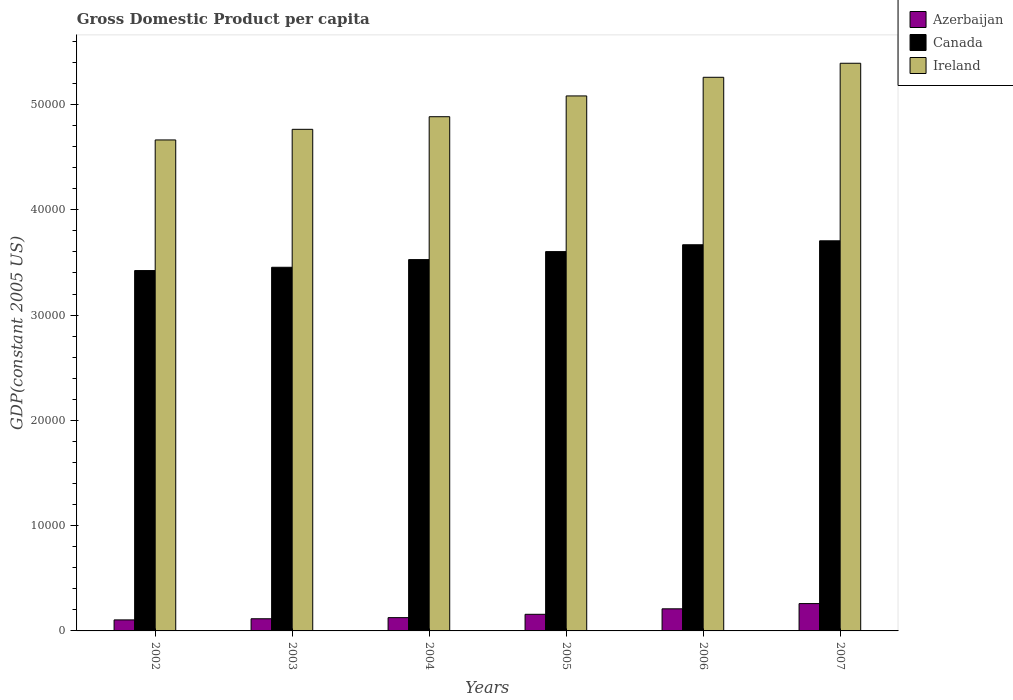How many different coloured bars are there?
Your answer should be compact. 3. How many groups of bars are there?
Offer a terse response. 6. Are the number of bars per tick equal to the number of legend labels?
Give a very brief answer. Yes. Are the number of bars on each tick of the X-axis equal?
Ensure brevity in your answer.  Yes. How many bars are there on the 6th tick from the left?
Provide a short and direct response. 3. How many bars are there on the 5th tick from the right?
Offer a very short reply. 3. What is the label of the 6th group of bars from the left?
Offer a terse response. 2007. In how many cases, is the number of bars for a given year not equal to the number of legend labels?
Your answer should be compact. 0. What is the GDP per capita in Azerbaijan in 2003?
Your answer should be compact. 1154.84. Across all years, what is the maximum GDP per capita in Ireland?
Offer a terse response. 5.39e+04. Across all years, what is the minimum GDP per capita in Azerbaijan?
Give a very brief answer. 1046.42. In which year was the GDP per capita in Canada maximum?
Provide a succinct answer. 2007. What is the total GDP per capita in Ireland in the graph?
Offer a very short reply. 3.00e+05. What is the difference between the GDP per capita in Ireland in 2002 and that in 2003?
Your answer should be compact. -1009.33. What is the difference between the GDP per capita in Azerbaijan in 2007 and the GDP per capita in Canada in 2005?
Make the answer very short. -3.34e+04. What is the average GDP per capita in Ireland per year?
Make the answer very short. 5.01e+04. In the year 2006, what is the difference between the GDP per capita in Azerbaijan and GDP per capita in Canada?
Offer a very short reply. -3.46e+04. In how many years, is the GDP per capita in Canada greater than 50000 US$?
Offer a very short reply. 0. What is the ratio of the GDP per capita in Azerbaijan in 2004 to that in 2006?
Keep it short and to the point. 0.6. Is the difference between the GDP per capita in Azerbaijan in 2004 and 2005 greater than the difference between the GDP per capita in Canada in 2004 and 2005?
Provide a succinct answer. Yes. What is the difference between the highest and the second highest GDP per capita in Azerbaijan?
Offer a very short reply. 496.35. What is the difference between the highest and the lowest GDP per capita in Ireland?
Give a very brief answer. 7283.82. In how many years, is the GDP per capita in Azerbaijan greater than the average GDP per capita in Azerbaijan taken over all years?
Keep it short and to the point. 2. What does the 2nd bar from the left in 2005 represents?
Provide a succinct answer. Canada. What does the 1st bar from the right in 2005 represents?
Provide a short and direct response. Ireland. What is the difference between two consecutive major ticks on the Y-axis?
Provide a succinct answer. 10000. Are the values on the major ticks of Y-axis written in scientific E-notation?
Give a very brief answer. No. Does the graph contain any zero values?
Offer a very short reply. No. How are the legend labels stacked?
Offer a very short reply. Vertical. What is the title of the graph?
Offer a terse response. Gross Domestic Product per capita. Does "Middle income" appear as one of the legend labels in the graph?
Offer a very short reply. No. What is the label or title of the Y-axis?
Provide a short and direct response. GDP(constant 2005 US). What is the GDP(constant 2005 US) of Azerbaijan in 2002?
Your answer should be very brief. 1046.42. What is the GDP(constant 2005 US) of Canada in 2002?
Keep it short and to the point. 3.42e+04. What is the GDP(constant 2005 US) in Ireland in 2002?
Your response must be concise. 4.66e+04. What is the GDP(constant 2005 US) of Azerbaijan in 2003?
Provide a succinct answer. 1154.84. What is the GDP(constant 2005 US) in Canada in 2003?
Your response must be concise. 3.45e+04. What is the GDP(constant 2005 US) in Ireland in 2003?
Provide a short and direct response. 4.76e+04. What is the GDP(constant 2005 US) of Azerbaijan in 2004?
Ensure brevity in your answer.  1261.54. What is the GDP(constant 2005 US) in Canada in 2004?
Provide a short and direct response. 3.53e+04. What is the GDP(constant 2005 US) in Ireland in 2004?
Provide a succinct answer. 4.88e+04. What is the GDP(constant 2005 US) in Azerbaijan in 2005?
Give a very brief answer. 1578.37. What is the GDP(constant 2005 US) in Canada in 2005?
Make the answer very short. 3.60e+04. What is the GDP(constant 2005 US) in Ireland in 2005?
Make the answer very short. 5.08e+04. What is the GDP(constant 2005 US) in Azerbaijan in 2006?
Ensure brevity in your answer.  2099.71. What is the GDP(constant 2005 US) in Canada in 2006?
Keep it short and to the point. 3.67e+04. What is the GDP(constant 2005 US) of Ireland in 2006?
Offer a very short reply. 5.26e+04. What is the GDP(constant 2005 US) of Azerbaijan in 2007?
Offer a terse response. 2596.06. What is the GDP(constant 2005 US) of Canada in 2007?
Offer a very short reply. 3.71e+04. What is the GDP(constant 2005 US) in Ireland in 2007?
Keep it short and to the point. 5.39e+04. Across all years, what is the maximum GDP(constant 2005 US) of Azerbaijan?
Offer a very short reply. 2596.06. Across all years, what is the maximum GDP(constant 2005 US) of Canada?
Provide a short and direct response. 3.71e+04. Across all years, what is the maximum GDP(constant 2005 US) of Ireland?
Keep it short and to the point. 5.39e+04. Across all years, what is the minimum GDP(constant 2005 US) in Azerbaijan?
Offer a very short reply. 1046.42. Across all years, what is the minimum GDP(constant 2005 US) in Canada?
Ensure brevity in your answer.  3.42e+04. Across all years, what is the minimum GDP(constant 2005 US) in Ireland?
Your response must be concise. 4.66e+04. What is the total GDP(constant 2005 US) in Azerbaijan in the graph?
Provide a succinct answer. 9736.94. What is the total GDP(constant 2005 US) of Canada in the graph?
Give a very brief answer. 2.14e+05. What is the total GDP(constant 2005 US) in Ireland in the graph?
Offer a very short reply. 3.00e+05. What is the difference between the GDP(constant 2005 US) of Azerbaijan in 2002 and that in 2003?
Offer a terse response. -108.42. What is the difference between the GDP(constant 2005 US) of Canada in 2002 and that in 2003?
Give a very brief answer. -313.16. What is the difference between the GDP(constant 2005 US) of Ireland in 2002 and that in 2003?
Make the answer very short. -1009.34. What is the difference between the GDP(constant 2005 US) in Azerbaijan in 2002 and that in 2004?
Offer a terse response. -215.12. What is the difference between the GDP(constant 2005 US) of Canada in 2002 and that in 2004?
Offer a terse response. -1042.13. What is the difference between the GDP(constant 2005 US) of Ireland in 2002 and that in 2004?
Offer a terse response. -2206.92. What is the difference between the GDP(constant 2005 US) in Azerbaijan in 2002 and that in 2005?
Keep it short and to the point. -531.95. What is the difference between the GDP(constant 2005 US) of Canada in 2002 and that in 2005?
Provide a succinct answer. -1800.79. What is the difference between the GDP(constant 2005 US) of Ireland in 2002 and that in 2005?
Your answer should be compact. -4181.31. What is the difference between the GDP(constant 2005 US) of Azerbaijan in 2002 and that in 2006?
Ensure brevity in your answer.  -1053.29. What is the difference between the GDP(constant 2005 US) of Canada in 2002 and that in 2006?
Keep it short and to the point. -2451.93. What is the difference between the GDP(constant 2005 US) of Ireland in 2002 and that in 2006?
Offer a terse response. -5950.66. What is the difference between the GDP(constant 2005 US) of Azerbaijan in 2002 and that in 2007?
Give a very brief answer. -1549.64. What is the difference between the GDP(constant 2005 US) in Canada in 2002 and that in 2007?
Provide a succinct answer. -2827.44. What is the difference between the GDP(constant 2005 US) of Ireland in 2002 and that in 2007?
Keep it short and to the point. -7283.82. What is the difference between the GDP(constant 2005 US) in Azerbaijan in 2003 and that in 2004?
Keep it short and to the point. -106.7. What is the difference between the GDP(constant 2005 US) in Canada in 2003 and that in 2004?
Provide a short and direct response. -728.97. What is the difference between the GDP(constant 2005 US) in Ireland in 2003 and that in 2004?
Ensure brevity in your answer.  -1197.58. What is the difference between the GDP(constant 2005 US) in Azerbaijan in 2003 and that in 2005?
Your answer should be very brief. -423.53. What is the difference between the GDP(constant 2005 US) of Canada in 2003 and that in 2005?
Offer a very short reply. -1487.63. What is the difference between the GDP(constant 2005 US) in Ireland in 2003 and that in 2005?
Your response must be concise. -3171.98. What is the difference between the GDP(constant 2005 US) of Azerbaijan in 2003 and that in 2006?
Make the answer very short. -944.87. What is the difference between the GDP(constant 2005 US) of Canada in 2003 and that in 2006?
Your answer should be very brief. -2138.76. What is the difference between the GDP(constant 2005 US) in Ireland in 2003 and that in 2006?
Your answer should be very brief. -4941.33. What is the difference between the GDP(constant 2005 US) in Azerbaijan in 2003 and that in 2007?
Give a very brief answer. -1441.23. What is the difference between the GDP(constant 2005 US) in Canada in 2003 and that in 2007?
Keep it short and to the point. -2514.27. What is the difference between the GDP(constant 2005 US) in Ireland in 2003 and that in 2007?
Provide a short and direct response. -6274.48. What is the difference between the GDP(constant 2005 US) of Azerbaijan in 2004 and that in 2005?
Provide a succinct answer. -316.83. What is the difference between the GDP(constant 2005 US) in Canada in 2004 and that in 2005?
Your answer should be compact. -758.66. What is the difference between the GDP(constant 2005 US) in Ireland in 2004 and that in 2005?
Offer a very short reply. -1974.4. What is the difference between the GDP(constant 2005 US) in Azerbaijan in 2004 and that in 2006?
Ensure brevity in your answer.  -838.17. What is the difference between the GDP(constant 2005 US) of Canada in 2004 and that in 2006?
Ensure brevity in your answer.  -1409.8. What is the difference between the GDP(constant 2005 US) in Ireland in 2004 and that in 2006?
Your response must be concise. -3743.75. What is the difference between the GDP(constant 2005 US) of Azerbaijan in 2004 and that in 2007?
Make the answer very short. -1334.52. What is the difference between the GDP(constant 2005 US) in Canada in 2004 and that in 2007?
Ensure brevity in your answer.  -1785.31. What is the difference between the GDP(constant 2005 US) in Ireland in 2004 and that in 2007?
Provide a succinct answer. -5076.9. What is the difference between the GDP(constant 2005 US) in Azerbaijan in 2005 and that in 2006?
Offer a very short reply. -521.34. What is the difference between the GDP(constant 2005 US) of Canada in 2005 and that in 2006?
Give a very brief answer. -651.14. What is the difference between the GDP(constant 2005 US) in Ireland in 2005 and that in 2006?
Keep it short and to the point. -1769.35. What is the difference between the GDP(constant 2005 US) in Azerbaijan in 2005 and that in 2007?
Ensure brevity in your answer.  -1017.7. What is the difference between the GDP(constant 2005 US) of Canada in 2005 and that in 2007?
Your answer should be compact. -1026.65. What is the difference between the GDP(constant 2005 US) of Ireland in 2005 and that in 2007?
Provide a short and direct response. -3102.5. What is the difference between the GDP(constant 2005 US) of Azerbaijan in 2006 and that in 2007?
Provide a succinct answer. -496.35. What is the difference between the GDP(constant 2005 US) in Canada in 2006 and that in 2007?
Your answer should be compact. -375.51. What is the difference between the GDP(constant 2005 US) of Ireland in 2006 and that in 2007?
Give a very brief answer. -1333.15. What is the difference between the GDP(constant 2005 US) of Azerbaijan in 2002 and the GDP(constant 2005 US) of Canada in 2003?
Ensure brevity in your answer.  -3.35e+04. What is the difference between the GDP(constant 2005 US) of Azerbaijan in 2002 and the GDP(constant 2005 US) of Ireland in 2003?
Offer a terse response. -4.66e+04. What is the difference between the GDP(constant 2005 US) in Canada in 2002 and the GDP(constant 2005 US) in Ireland in 2003?
Ensure brevity in your answer.  -1.34e+04. What is the difference between the GDP(constant 2005 US) in Azerbaijan in 2002 and the GDP(constant 2005 US) in Canada in 2004?
Your answer should be compact. -3.42e+04. What is the difference between the GDP(constant 2005 US) in Azerbaijan in 2002 and the GDP(constant 2005 US) in Ireland in 2004?
Your answer should be very brief. -4.78e+04. What is the difference between the GDP(constant 2005 US) of Canada in 2002 and the GDP(constant 2005 US) of Ireland in 2004?
Provide a short and direct response. -1.46e+04. What is the difference between the GDP(constant 2005 US) of Azerbaijan in 2002 and the GDP(constant 2005 US) of Canada in 2005?
Give a very brief answer. -3.50e+04. What is the difference between the GDP(constant 2005 US) of Azerbaijan in 2002 and the GDP(constant 2005 US) of Ireland in 2005?
Provide a succinct answer. -4.98e+04. What is the difference between the GDP(constant 2005 US) in Canada in 2002 and the GDP(constant 2005 US) in Ireland in 2005?
Your answer should be very brief. -1.66e+04. What is the difference between the GDP(constant 2005 US) of Azerbaijan in 2002 and the GDP(constant 2005 US) of Canada in 2006?
Offer a very short reply. -3.56e+04. What is the difference between the GDP(constant 2005 US) of Azerbaijan in 2002 and the GDP(constant 2005 US) of Ireland in 2006?
Offer a terse response. -5.15e+04. What is the difference between the GDP(constant 2005 US) of Canada in 2002 and the GDP(constant 2005 US) of Ireland in 2006?
Provide a short and direct response. -1.84e+04. What is the difference between the GDP(constant 2005 US) in Azerbaijan in 2002 and the GDP(constant 2005 US) in Canada in 2007?
Your answer should be very brief. -3.60e+04. What is the difference between the GDP(constant 2005 US) in Azerbaijan in 2002 and the GDP(constant 2005 US) in Ireland in 2007?
Your answer should be very brief. -5.29e+04. What is the difference between the GDP(constant 2005 US) in Canada in 2002 and the GDP(constant 2005 US) in Ireland in 2007?
Provide a succinct answer. -1.97e+04. What is the difference between the GDP(constant 2005 US) in Azerbaijan in 2003 and the GDP(constant 2005 US) in Canada in 2004?
Your answer should be compact. -3.41e+04. What is the difference between the GDP(constant 2005 US) of Azerbaijan in 2003 and the GDP(constant 2005 US) of Ireland in 2004?
Your answer should be compact. -4.77e+04. What is the difference between the GDP(constant 2005 US) in Canada in 2003 and the GDP(constant 2005 US) in Ireland in 2004?
Offer a very short reply. -1.43e+04. What is the difference between the GDP(constant 2005 US) in Azerbaijan in 2003 and the GDP(constant 2005 US) in Canada in 2005?
Your answer should be compact. -3.49e+04. What is the difference between the GDP(constant 2005 US) in Azerbaijan in 2003 and the GDP(constant 2005 US) in Ireland in 2005?
Give a very brief answer. -4.97e+04. What is the difference between the GDP(constant 2005 US) of Canada in 2003 and the GDP(constant 2005 US) of Ireland in 2005?
Give a very brief answer. -1.63e+04. What is the difference between the GDP(constant 2005 US) in Azerbaijan in 2003 and the GDP(constant 2005 US) in Canada in 2006?
Offer a terse response. -3.55e+04. What is the difference between the GDP(constant 2005 US) in Azerbaijan in 2003 and the GDP(constant 2005 US) in Ireland in 2006?
Ensure brevity in your answer.  -5.14e+04. What is the difference between the GDP(constant 2005 US) in Canada in 2003 and the GDP(constant 2005 US) in Ireland in 2006?
Offer a very short reply. -1.80e+04. What is the difference between the GDP(constant 2005 US) of Azerbaijan in 2003 and the GDP(constant 2005 US) of Canada in 2007?
Your response must be concise. -3.59e+04. What is the difference between the GDP(constant 2005 US) in Azerbaijan in 2003 and the GDP(constant 2005 US) in Ireland in 2007?
Offer a very short reply. -5.28e+04. What is the difference between the GDP(constant 2005 US) in Canada in 2003 and the GDP(constant 2005 US) in Ireland in 2007?
Your response must be concise. -1.94e+04. What is the difference between the GDP(constant 2005 US) of Azerbaijan in 2004 and the GDP(constant 2005 US) of Canada in 2005?
Make the answer very short. -3.48e+04. What is the difference between the GDP(constant 2005 US) of Azerbaijan in 2004 and the GDP(constant 2005 US) of Ireland in 2005?
Make the answer very short. -4.96e+04. What is the difference between the GDP(constant 2005 US) of Canada in 2004 and the GDP(constant 2005 US) of Ireland in 2005?
Your answer should be compact. -1.55e+04. What is the difference between the GDP(constant 2005 US) in Azerbaijan in 2004 and the GDP(constant 2005 US) in Canada in 2006?
Offer a terse response. -3.54e+04. What is the difference between the GDP(constant 2005 US) in Azerbaijan in 2004 and the GDP(constant 2005 US) in Ireland in 2006?
Keep it short and to the point. -5.13e+04. What is the difference between the GDP(constant 2005 US) in Canada in 2004 and the GDP(constant 2005 US) in Ireland in 2006?
Your answer should be very brief. -1.73e+04. What is the difference between the GDP(constant 2005 US) in Azerbaijan in 2004 and the GDP(constant 2005 US) in Canada in 2007?
Your response must be concise. -3.58e+04. What is the difference between the GDP(constant 2005 US) of Azerbaijan in 2004 and the GDP(constant 2005 US) of Ireland in 2007?
Offer a terse response. -5.27e+04. What is the difference between the GDP(constant 2005 US) in Canada in 2004 and the GDP(constant 2005 US) in Ireland in 2007?
Your answer should be very brief. -1.86e+04. What is the difference between the GDP(constant 2005 US) of Azerbaijan in 2005 and the GDP(constant 2005 US) of Canada in 2006?
Keep it short and to the point. -3.51e+04. What is the difference between the GDP(constant 2005 US) of Azerbaijan in 2005 and the GDP(constant 2005 US) of Ireland in 2006?
Offer a very short reply. -5.10e+04. What is the difference between the GDP(constant 2005 US) in Canada in 2005 and the GDP(constant 2005 US) in Ireland in 2006?
Provide a short and direct response. -1.66e+04. What is the difference between the GDP(constant 2005 US) in Azerbaijan in 2005 and the GDP(constant 2005 US) in Canada in 2007?
Your answer should be compact. -3.55e+04. What is the difference between the GDP(constant 2005 US) of Azerbaijan in 2005 and the GDP(constant 2005 US) of Ireland in 2007?
Offer a terse response. -5.23e+04. What is the difference between the GDP(constant 2005 US) of Canada in 2005 and the GDP(constant 2005 US) of Ireland in 2007?
Your response must be concise. -1.79e+04. What is the difference between the GDP(constant 2005 US) of Azerbaijan in 2006 and the GDP(constant 2005 US) of Canada in 2007?
Provide a succinct answer. -3.50e+04. What is the difference between the GDP(constant 2005 US) of Azerbaijan in 2006 and the GDP(constant 2005 US) of Ireland in 2007?
Ensure brevity in your answer.  -5.18e+04. What is the difference between the GDP(constant 2005 US) of Canada in 2006 and the GDP(constant 2005 US) of Ireland in 2007?
Give a very brief answer. -1.72e+04. What is the average GDP(constant 2005 US) in Azerbaijan per year?
Offer a very short reply. 1622.82. What is the average GDP(constant 2005 US) in Canada per year?
Give a very brief answer. 3.56e+04. What is the average GDP(constant 2005 US) of Ireland per year?
Provide a succinct answer. 5.01e+04. In the year 2002, what is the difference between the GDP(constant 2005 US) in Azerbaijan and GDP(constant 2005 US) in Canada?
Give a very brief answer. -3.32e+04. In the year 2002, what is the difference between the GDP(constant 2005 US) of Azerbaijan and GDP(constant 2005 US) of Ireland?
Your answer should be compact. -4.56e+04. In the year 2002, what is the difference between the GDP(constant 2005 US) of Canada and GDP(constant 2005 US) of Ireland?
Make the answer very short. -1.24e+04. In the year 2003, what is the difference between the GDP(constant 2005 US) in Azerbaijan and GDP(constant 2005 US) in Canada?
Make the answer very short. -3.34e+04. In the year 2003, what is the difference between the GDP(constant 2005 US) of Azerbaijan and GDP(constant 2005 US) of Ireland?
Offer a terse response. -4.65e+04. In the year 2003, what is the difference between the GDP(constant 2005 US) of Canada and GDP(constant 2005 US) of Ireland?
Offer a very short reply. -1.31e+04. In the year 2004, what is the difference between the GDP(constant 2005 US) of Azerbaijan and GDP(constant 2005 US) of Canada?
Offer a terse response. -3.40e+04. In the year 2004, what is the difference between the GDP(constant 2005 US) of Azerbaijan and GDP(constant 2005 US) of Ireland?
Offer a terse response. -4.76e+04. In the year 2004, what is the difference between the GDP(constant 2005 US) of Canada and GDP(constant 2005 US) of Ireland?
Your response must be concise. -1.36e+04. In the year 2005, what is the difference between the GDP(constant 2005 US) of Azerbaijan and GDP(constant 2005 US) of Canada?
Provide a succinct answer. -3.44e+04. In the year 2005, what is the difference between the GDP(constant 2005 US) of Azerbaijan and GDP(constant 2005 US) of Ireland?
Keep it short and to the point. -4.92e+04. In the year 2005, what is the difference between the GDP(constant 2005 US) of Canada and GDP(constant 2005 US) of Ireland?
Keep it short and to the point. -1.48e+04. In the year 2006, what is the difference between the GDP(constant 2005 US) of Azerbaijan and GDP(constant 2005 US) of Canada?
Your response must be concise. -3.46e+04. In the year 2006, what is the difference between the GDP(constant 2005 US) in Azerbaijan and GDP(constant 2005 US) in Ireland?
Make the answer very short. -5.05e+04. In the year 2006, what is the difference between the GDP(constant 2005 US) in Canada and GDP(constant 2005 US) in Ireland?
Offer a terse response. -1.59e+04. In the year 2007, what is the difference between the GDP(constant 2005 US) in Azerbaijan and GDP(constant 2005 US) in Canada?
Your answer should be very brief. -3.45e+04. In the year 2007, what is the difference between the GDP(constant 2005 US) in Azerbaijan and GDP(constant 2005 US) in Ireland?
Offer a very short reply. -5.13e+04. In the year 2007, what is the difference between the GDP(constant 2005 US) of Canada and GDP(constant 2005 US) of Ireland?
Provide a succinct answer. -1.69e+04. What is the ratio of the GDP(constant 2005 US) of Azerbaijan in 2002 to that in 2003?
Provide a succinct answer. 0.91. What is the ratio of the GDP(constant 2005 US) in Canada in 2002 to that in 2003?
Make the answer very short. 0.99. What is the ratio of the GDP(constant 2005 US) in Ireland in 2002 to that in 2003?
Provide a short and direct response. 0.98. What is the ratio of the GDP(constant 2005 US) of Azerbaijan in 2002 to that in 2004?
Ensure brevity in your answer.  0.83. What is the ratio of the GDP(constant 2005 US) in Canada in 2002 to that in 2004?
Provide a short and direct response. 0.97. What is the ratio of the GDP(constant 2005 US) in Ireland in 2002 to that in 2004?
Keep it short and to the point. 0.95. What is the ratio of the GDP(constant 2005 US) of Azerbaijan in 2002 to that in 2005?
Offer a terse response. 0.66. What is the ratio of the GDP(constant 2005 US) of Canada in 2002 to that in 2005?
Offer a very short reply. 0.95. What is the ratio of the GDP(constant 2005 US) of Ireland in 2002 to that in 2005?
Provide a succinct answer. 0.92. What is the ratio of the GDP(constant 2005 US) of Azerbaijan in 2002 to that in 2006?
Keep it short and to the point. 0.5. What is the ratio of the GDP(constant 2005 US) of Canada in 2002 to that in 2006?
Make the answer very short. 0.93. What is the ratio of the GDP(constant 2005 US) in Ireland in 2002 to that in 2006?
Offer a terse response. 0.89. What is the ratio of the GDP(constant 2005 US) in Azerbaijan in 2002 to that in 2007?
Keep it short and to the point. 0.4. What is the ratio of the GDP(constant 2005 US) in Canada in 2002 to that in 2007?
Ensure brevity in your answer.  0.92. What is the ratio of the GDP(constant 2005 US) in Ireland in 2002 to that in 2007?
Make the answer very short. 0.86. What is the ratio of the GDP(constant 2005 US) in Azerbaijan in 2003 to that in 2004?
Ensure brevity in your answer.  0.92. What is the ratio of the GDP(constant 2005 US) in Canada in 2003 to that in 2004?
Ensure brevity in your answer.  0.98. What is the ratio of the GDP(constant 2005 US) of Ireland in 2003 to that in 2004?
Give a very brief answer. 0.98. What is the ratio of the GDP(constant 2005 US) in Azerbaijan in 2003 to that in 2005?
Keep it short and to the point. 0.73. What is the ratio of the GDP(constant 2005 US) in Canada in 2003 to that in 2005?
Ensure brevity in your answer.  0.96. What is the ratio of the GDP(constant 2005 US) in Ireland in 2003 to that in 2005?
Provide a short and direct response. 0.94. What is the ratio of the GDP(constant 2005 US) in Azerbaijan in 2003 to that in 2006?
Keep it short and to the point. 0.55. What is the ratio of the GDP(constant 2005 US) in Canada in 2003 to that in 2006?
Offer a very short reply. 0.94. What is the ratio of the GDP(constant 2005 US) in Ireland in 2003 to that in 2006?
Your response must be concise. 0.91. What is the ratio of the GDP(constant 2005 US) of Azerbaijan in 2003 to that in 2007?
Offer a very short reply. 0.44. What is the ratio of the GDP(constant 2005 US) of Canada in 2003 to that in 2007?
Provide a short and direct response. 0.93. What is the ratio of the GDP(constant 2005 US) in Ireland in 2003 to that in 2007?
Keep it short and to the point. 0.88. What is the ratio of the GDP(constant 2005 US) of Azerbaijan in 2004 to that in 2005?
Give a very brief answer. 0.8. What is the ratio of the GDP(constant 2005 US) of Canada in 2004 to that in 2005?
Your response must be concise. 0.98. What is the ratio of the GDP(constant 2005 US) in Ireland in 2004 to that in 2005?
Provide a succinct answer. 0.96. What is the ratio of the GDP(constant 2005 US) of Azerbaijan in 2004 to that in 2006?
Offer a terse response. 0.6. What is the ratio of the GDP(constant 2005 US) in Canada in 2004 to that in 2006?
Ensure brevity in your answer.  0.96. What is the ratio of the GDP(constant 2005 US) in Ireland in 2004 to that in 2006?
Offer a terse response. 0.93. What is the ratio of the GDP(constant 2005 US) in Azerbaijan in 2004 to that in 2007?
Your response must be concise. 0.49. What is the ratio of the GDP(constant 2005 US) in Canada in 2004 to that in 2007?
Your answer should be compact. 0.95. What is the ratio of the GDP(constant 2005 US) of Ireland in 2004 to that in 2007?
Make the answer very short. 0.91. What is the ratio of the GDP(constant 2005 US) in Azerbaijan in 2005 to that in 2006?
Keep it short and to the point. 0.75. What is the ratio of the GDP(constant 2005 US) of Canada in 2005 to that in 2006?
Provide a short and direct response. 0.98. What is the ratio of the GDP(constant 2005 US) in Ireland in 2005 to that in 2006?
Offer a very short reply. 0.97. What is the ratio of the GDP(constant 2005 US) of Azerbaijan in 2005 to that in 2007?
Offer a terse response. 0.61. What is the ratio of the GDP(constant 2005 US) in Canada in 2005 to that in 2007?
Provide a succinct answer. 0.97. What is the ratio of the GDP(constant 2005 US) in Ireland in 2005 to that in 2007?
Provide a short and direct response. 0.94. What is the ratio of the GDP(constant 2005 US) in Azerbaijan in 2006 to that in 2007?
Ensure brevity in your answer.  0.81. What is the ratio of the GDP(constant 2005 US) in Ireland in 2006 to that in 2007?
Your answer should be very brief. 0.98. What is the difference between the highest and the second highest GDP(constant 2005 US) in Azerbaijan?
Make the answer very short. 496.35. What is the difference between the highest and the second highest GDP(constant 2005 US) of Canada?
Ensure brevity in your answer.  375.51. What is the difference between the highest and the second highest GDP(constant 2005 US) in Ireland?
Offer a very short reply. 1333.15. What is the difference between the highest and the lowest GDP(constant 2005 US) of Azerbaijan?
Offer a terse response. 1549.64. What is the difference between the highest and the lowest GDP(constant 2005 US) in Canada?
Ensure brevity in your answer.  2827.44. What is the difference between the highest and the lowest GDP(constant 2005 US) of Ireland?
Provide a succinct answer. 7283.82. 